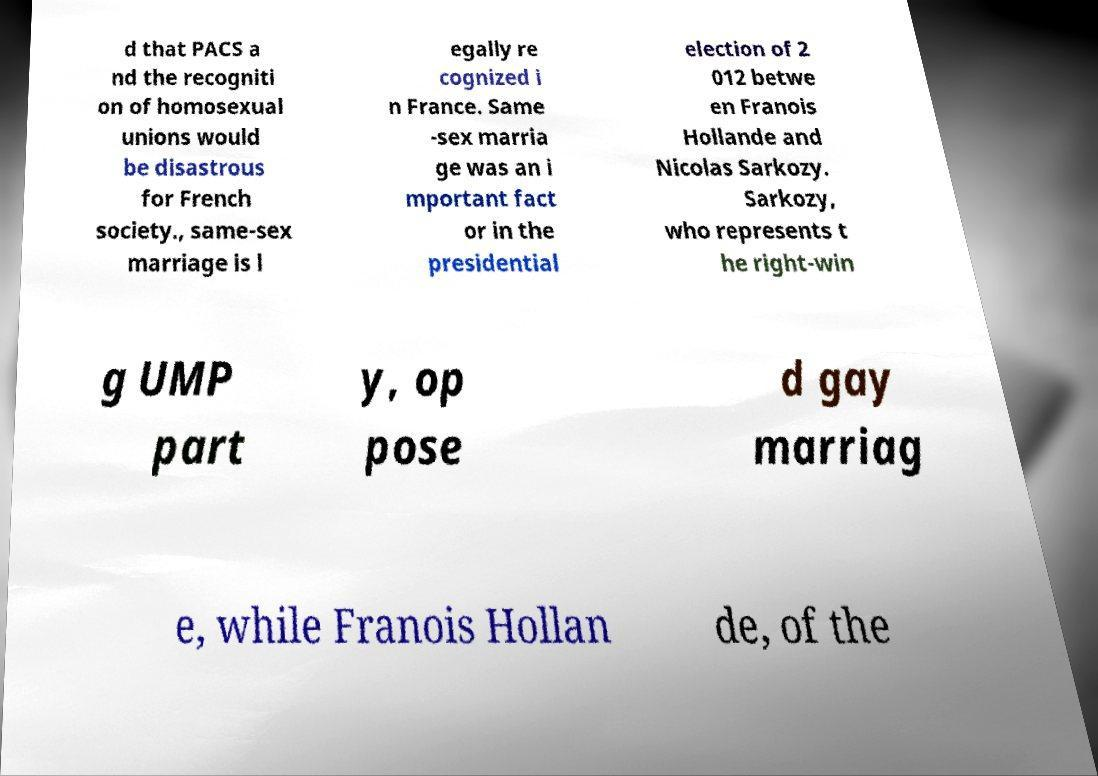There's text embedded in this image that I need extracted. Can you transcribe it verbatim? d that PACS a nd the recogniti on of homosexual unions would be disastrous for French society., same-sex marriage is l egally re cognized i n France. Same -sex marria ge was an i mportant fact or in the presidential election of 2 012 betwe en Franois Hollande and Nicolas Sarkozy. Sarkozy, who represents t he right-win g UMP part y, op pose d gay marriag e, while Franois Hollan de, of the 